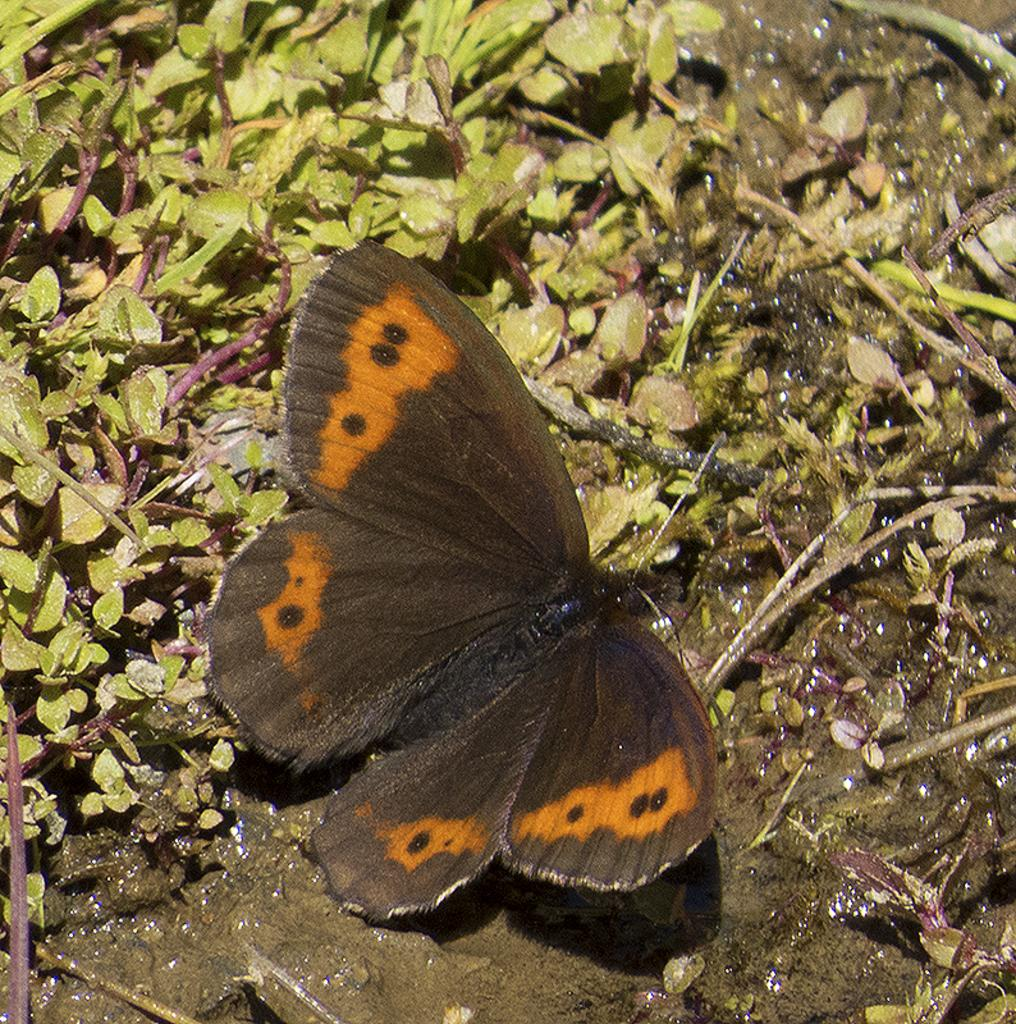What type of insect is in the image? There is a black butterfly in the image. What can be observed on the butterfly's wings? The butterfly has designs on it. What natural element is visible in the image? There is water visible in the image. What type of vegetation is present in the image? There is grass in the image. What unit of measurement is used to express the butterfly's regret in the image? There is no indication of regret or any unit of measurement in the image; it simply features a black butterfly with designs on its wings. 